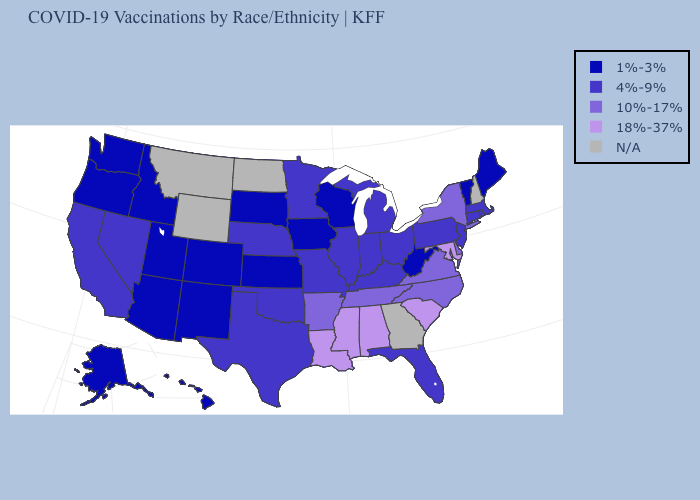What is the value of Oklahoma?
Concise answer only. 4%-9%. Name the states that have a value in the range 1%-3%?
Be succinct. Alaska, Arizona, Colorado, Hawaii, Idaho, Iowa, Kansas, Maine, New Mexico, Oregon, South Dakota, Utah, Vermont, Washington, West Virginia, Wisconsin. What is the value of Minnesota?
Give a very brief answer. 4%-9%. Name the states that have a value in the range N/A?
Answer briefly. Georgia, Montana, New Hampshire, North Dakota, Wyoming. Does Alaska have the lowest value in the USA?
Write a very short answer. Yes. Name the states that have a value in the range 18%-37%?
Short answer required. Alabama, Louisiana, Maryland, Mississippi, South Carolina. What is the highest value in states that border Nebraska?
Give a very brief answer. 4%-9%. Name the states that have a value in the range 18%-37%?
Short answer required. Alabama, Louisiana, Maryland, Mississippi, South Carolina. Does the first symbol in the legend represent the smallest category?
Write a very short answer. Yes. Name the states that have a value in the range N/A?
Short answer required. Georgia, Montana, New Hampshire, North Dakota, Wyoming. What is the value of Rhode Island?
Short answer required. 4%-9%. Name the states that have a value in the range 1%-3%?
Short answer required. Alaska, Arizona, Colorado, Hawaii, Idaho, Iowa, Kansas, Maine, New Mexico, Oregon, South Dakota, Utah, Vermont, Washington, West Virginia, Wisconsin. What is the value of Maine?
Quick response, please. 1%-3%. What is the highest value in the USA?
Keep it brief. 18%-37%. Among the states that border Connecticut , which have the lowest value?
Quick response, please. Massachusetts, Rhode Island. 